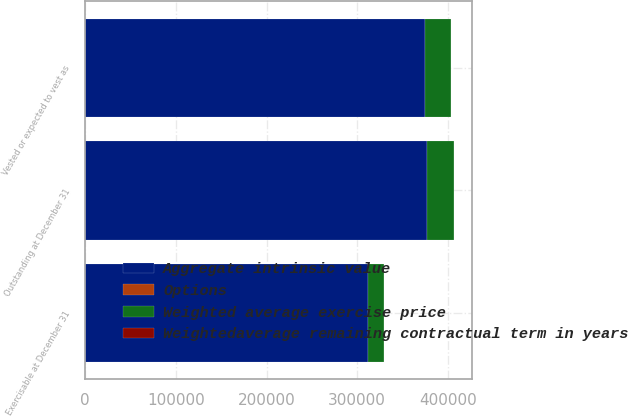Convert chart to OTSL. <chart><loc_0><loc_0><loc_500><loc_500><stacked_bar_chart><ecel><fcel>Outstanding at December 31<fcel>Vested or expected to vest as<fcel>Exercisable at December 31<nl><fcel>Weighted average exercise price<fcel>29273<fcel>28756<fcel>17419<nl><fcel>Weightedaverage remaining contractual term in years<fcel>60.41<fcel>60.25<fcel>55.36<nl><fcel>Options<fcel>6.2<fcel>6.2<fcel>4.6<nl><fcel>Aggregate intrinsic value<fcel>377120<fcel>375093<fcel>312381<nl></chart> 